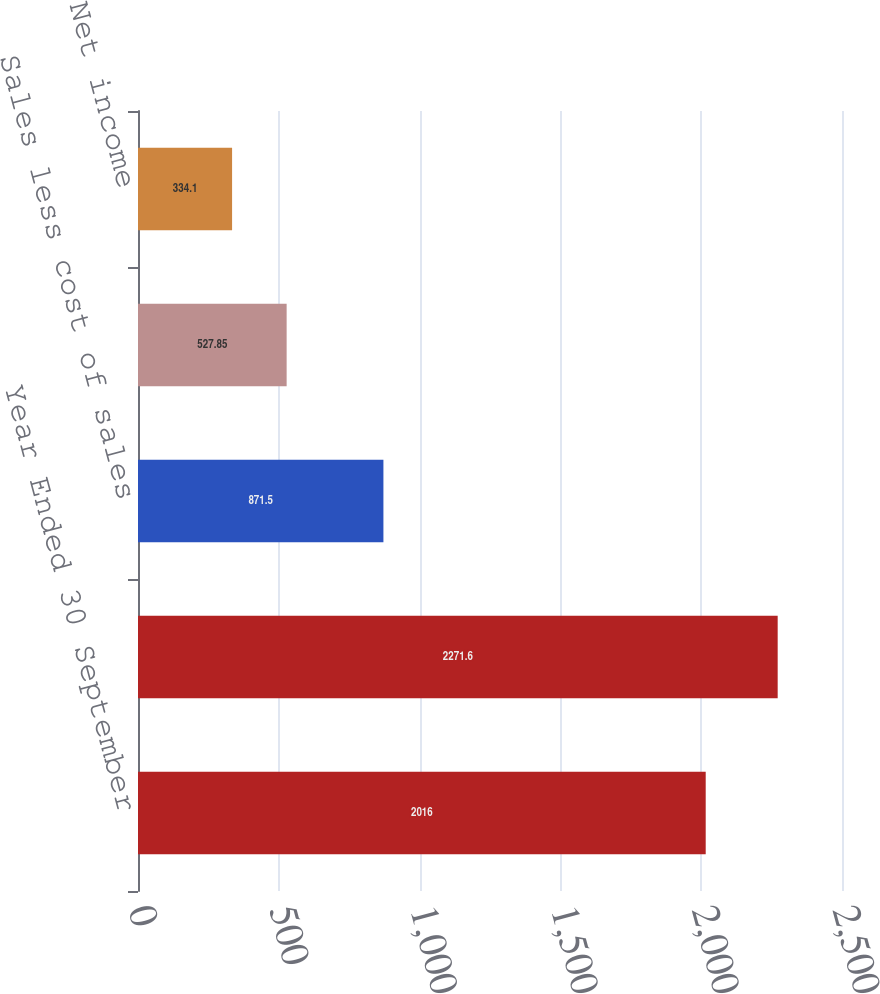Convert chart. <chart><loc_0><loc_0><loc_500><loc_500><bar_chart><fcel>Year Ended 30 September<fcel>Net sales<fcel>Sales less cost of sales<fcel>Operating income<fcel>Net income<nl><fcel>2016<fcel>2271.6<fcel>871.5<fcel>527.85<fcel>334.1<nl></chart> 